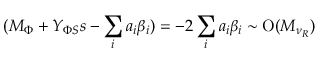Convert formula to latex. <formula><loc_0><loc_0><loc_500><loc_500>( M _ { \Phi } + Y _ { \Phi S } s - \sum _ { i } a _ { i } \beta _ { i } ) = - 2 \sum _ { i } a _ { i } \beta _ { i } \sim O ( M _ { \nu _ { R } } )</formula> 